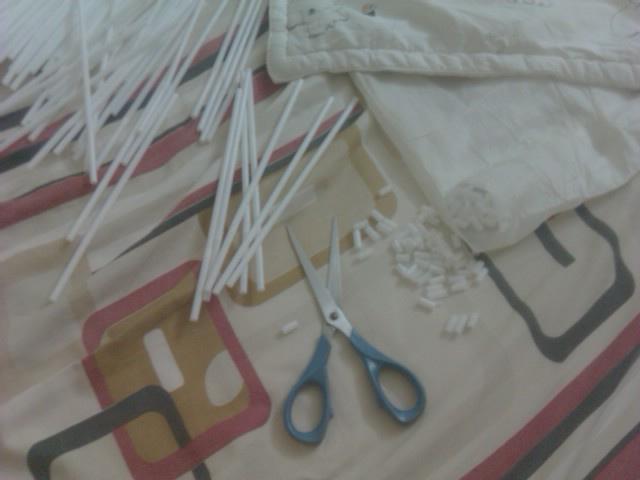What is the scissor used for?
Quick response, please. Cutting. What type of fabric are the scissors laying on?
Keep it brief. Cotton. Can a QR code be seen?
Answer briefly. No. What are the scissors cutting?
Concise answer only. Straws. Is this a tailor's shop?
Be succinct. Yes. 